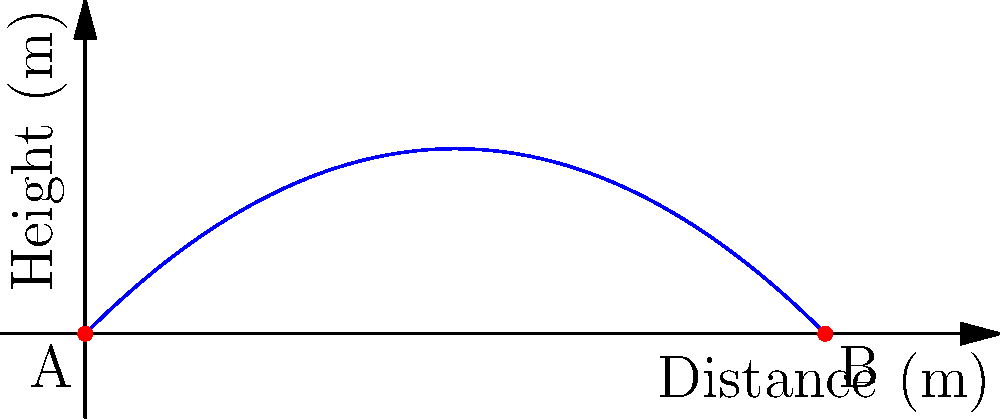During an outdoor recovery activity, you throw a ball to your friend. The ball is thrown with an initial velocity of 10 m/s at an angle of 45° to the horizontal. Assuming air resistance is negligible, what is the maximum height reached by the ball during its flight? To find the maximum height, we can follow these steps:

1) The vertical component of the initial velocity is:
   $v_{0y} = v_0 \sin \theta = 10 \cdot \sin 45° = 10 \cdot \frac{\sqrt{2}}{2} \approx 7.07$ m/s

2) The time to reach the maximum height is when the vertical velocity becomes zero:
   $t_{max} = \frac{v_{0y}}{g} = \frac{7.07}{9.8} \approx 0.72$ s

3) The maximum height can be calculated using the equation:
   $h_{max} = v_{0y}t - \frac{1}{2}gt^2$

4) Substituting the values:
   $h_{max} = 7.07 \cdot 0.72 - \frac{1}{2} \cdot 9.8 \cdot 0.72^2$
   $h_{max} = 5.09 - 2.54 = 2.55$ m

Therefore, the maximum height reached by the ball is approximately 2.55 meters.
Answer: 2.55 m 